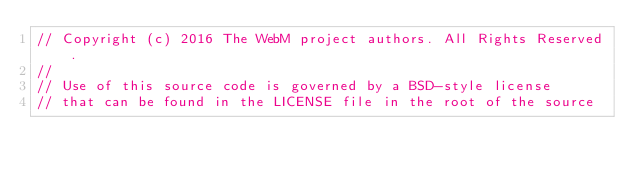Convert code to text. <code><loc_0><loc_0><loc_500><loc_500><_C++_>// Copyright (c) 2016 The WebM project authors. All Rights Reserved.
//
// Use of this source code is governed by a BSD-style license
// that can be found in the LICENSE file in the root of the source</code> 